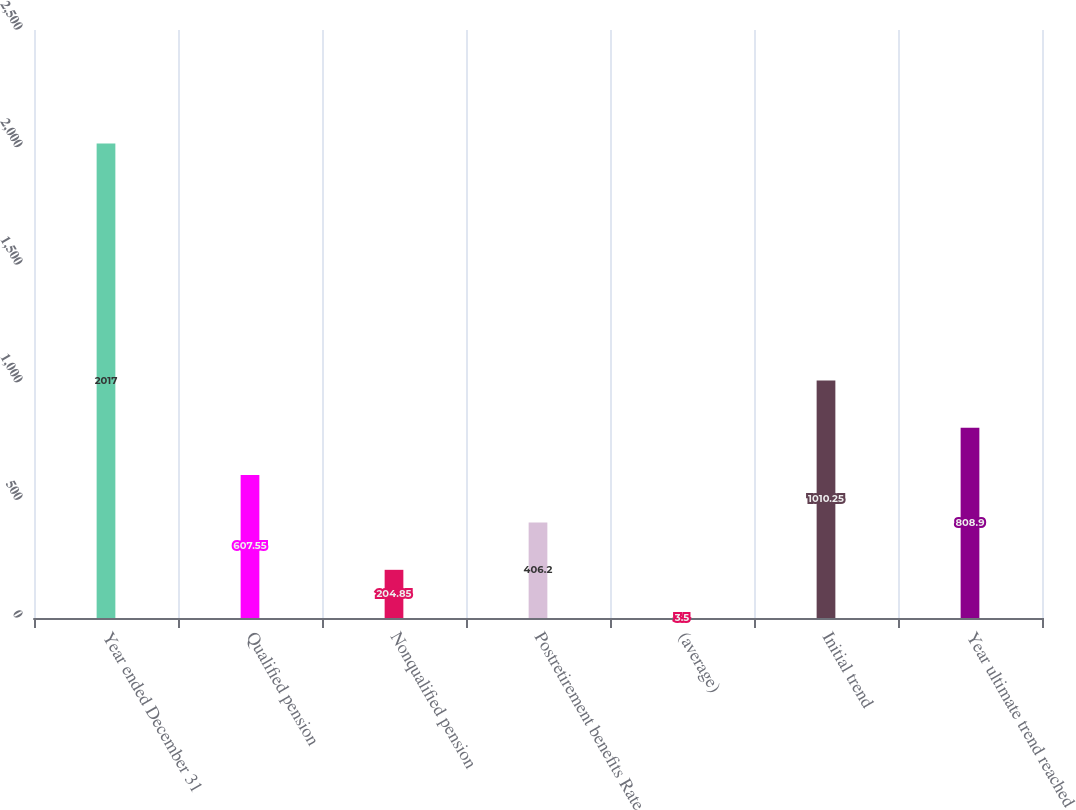<chart> <loc_0><loc_0><loc_500><loc_500><bar_chart><fcel>Year ended December 31<fcel>Qualified pension<fcel>Nonqualified pension<fcel>Postretirement benefits Rate<fcel>(average)<fcel>Initial trend<fcel>Year ultimate trend reached<nl><fcel>2017<fcel>607.55<fcel>204.85<fcel>406.2<fcel>3.5<fcel>1010.25<fcel>808.9<nl></chart> 